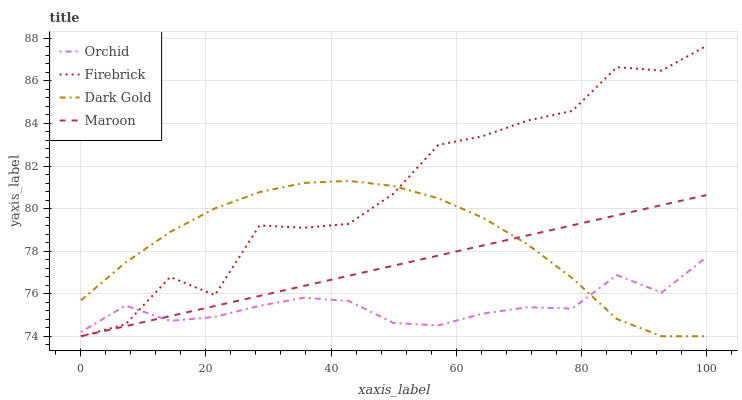Does Orchid have the minimum area under the curve?
Answer yes or no. Yes. Does Firebrick have the maximum area under the curve?
Answer yes or no. Yes. Does Dark Gold have the minimum area under the curve?
Answer yes or no. No. Does Dark Gold have the maximum area under the curve?
Answer yes or no. No. Is Maroon the smoothest?
Answer yes or no. Yes. Is Firebrick the roughest?
Answer yes or no. Yes. Is Dark Gold the smoothest?
Answer yes or no. No. Is Dark Gold the roughest?
Answer yes or no. No. Does Firebrick have the lowest value?
Answer yes or no. Yes. Does Orchid have the lowest value?
Answer yes or no. No. Does Firebrick have the highest value?
Answer yes or no. Yes. Does Dark Gold have the highest value?
Answer yes or no. No. Does Dark Gold intersect Firebrick?
Answer yes or no. Yes. Is Dark Gold less than Firebrick?
Answer yes or no. No. Is Dark Gold greater than Firebrick?
Answer yes or no. No. 